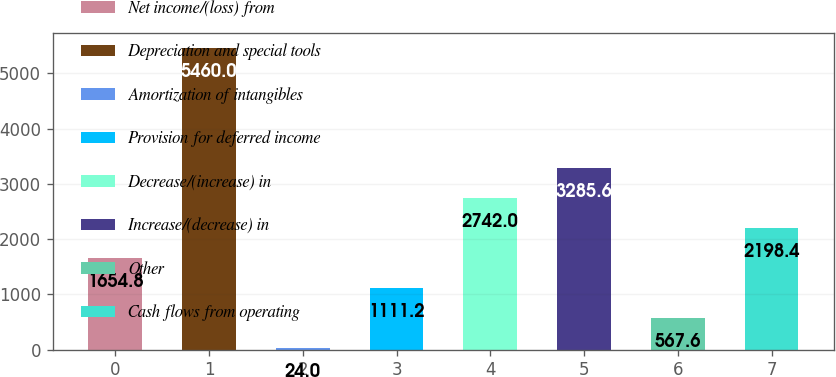Convert chart to OTSL. <chart><loc_0><loc_0><loc_500><loc_500><bar_chart><fcel>Net income/(loss) from<fcel>Depreciation and special tools<fcel>Amortization of intangibles<fcel>Provision for deferred income<fcel>Decrease/(increase) in<fcel>Increase/(decrease) in<fcel>Other<fcel>Cash flows from operating<nl><fcel>1654.8<fcel>5460<fcel>24<fcel>1111.2<fcel>2742<fcel>3285.6<fcel>567.6<fcel>2198.4<nl></chart> 